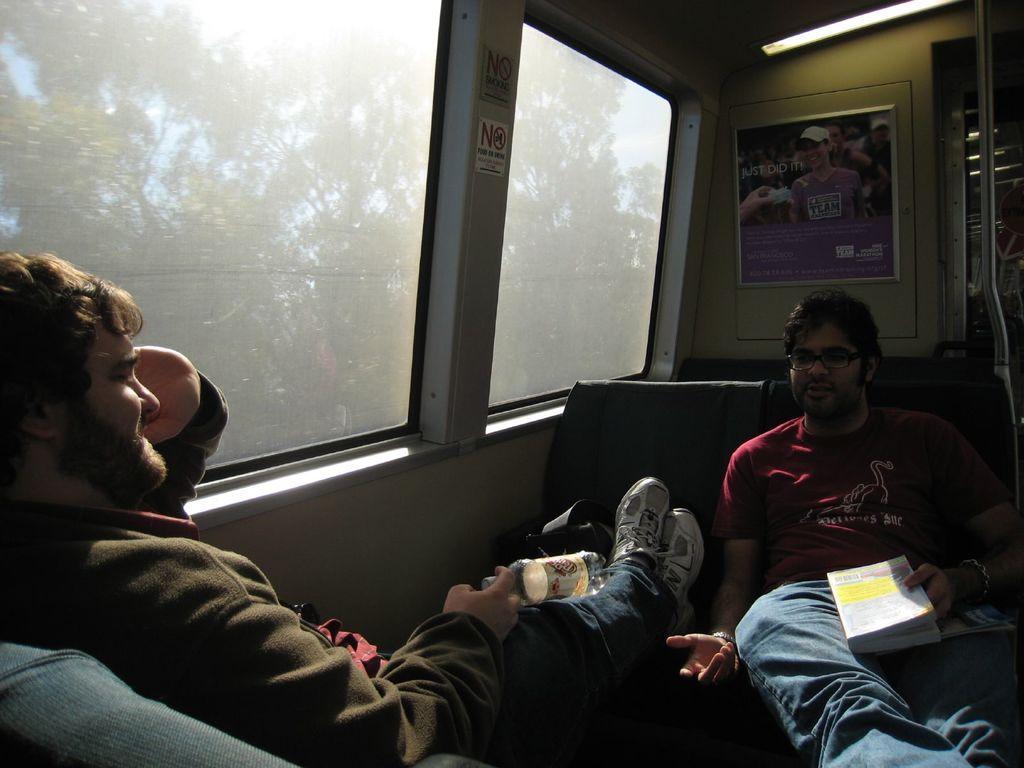How would you summarize this image in a sentence or two? In this image we can see two people sitting on the sofa, there is a poster on the wall, on the right there is a window, trees, we can see the sky. 